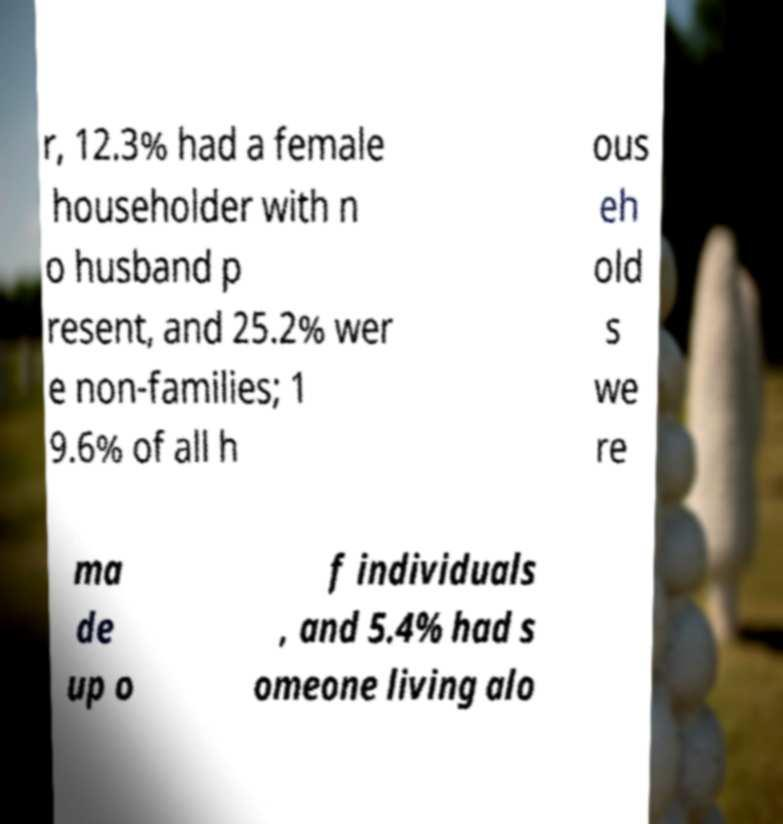Could you extract and type out the text from this image? r, 12.3% had a female householder with n o husband p resent, and 25.2% wer e non-families; 1 9.6% of all h ous eh old s we re ma de up o f individuals , and 5.4% had s omeone living alo 